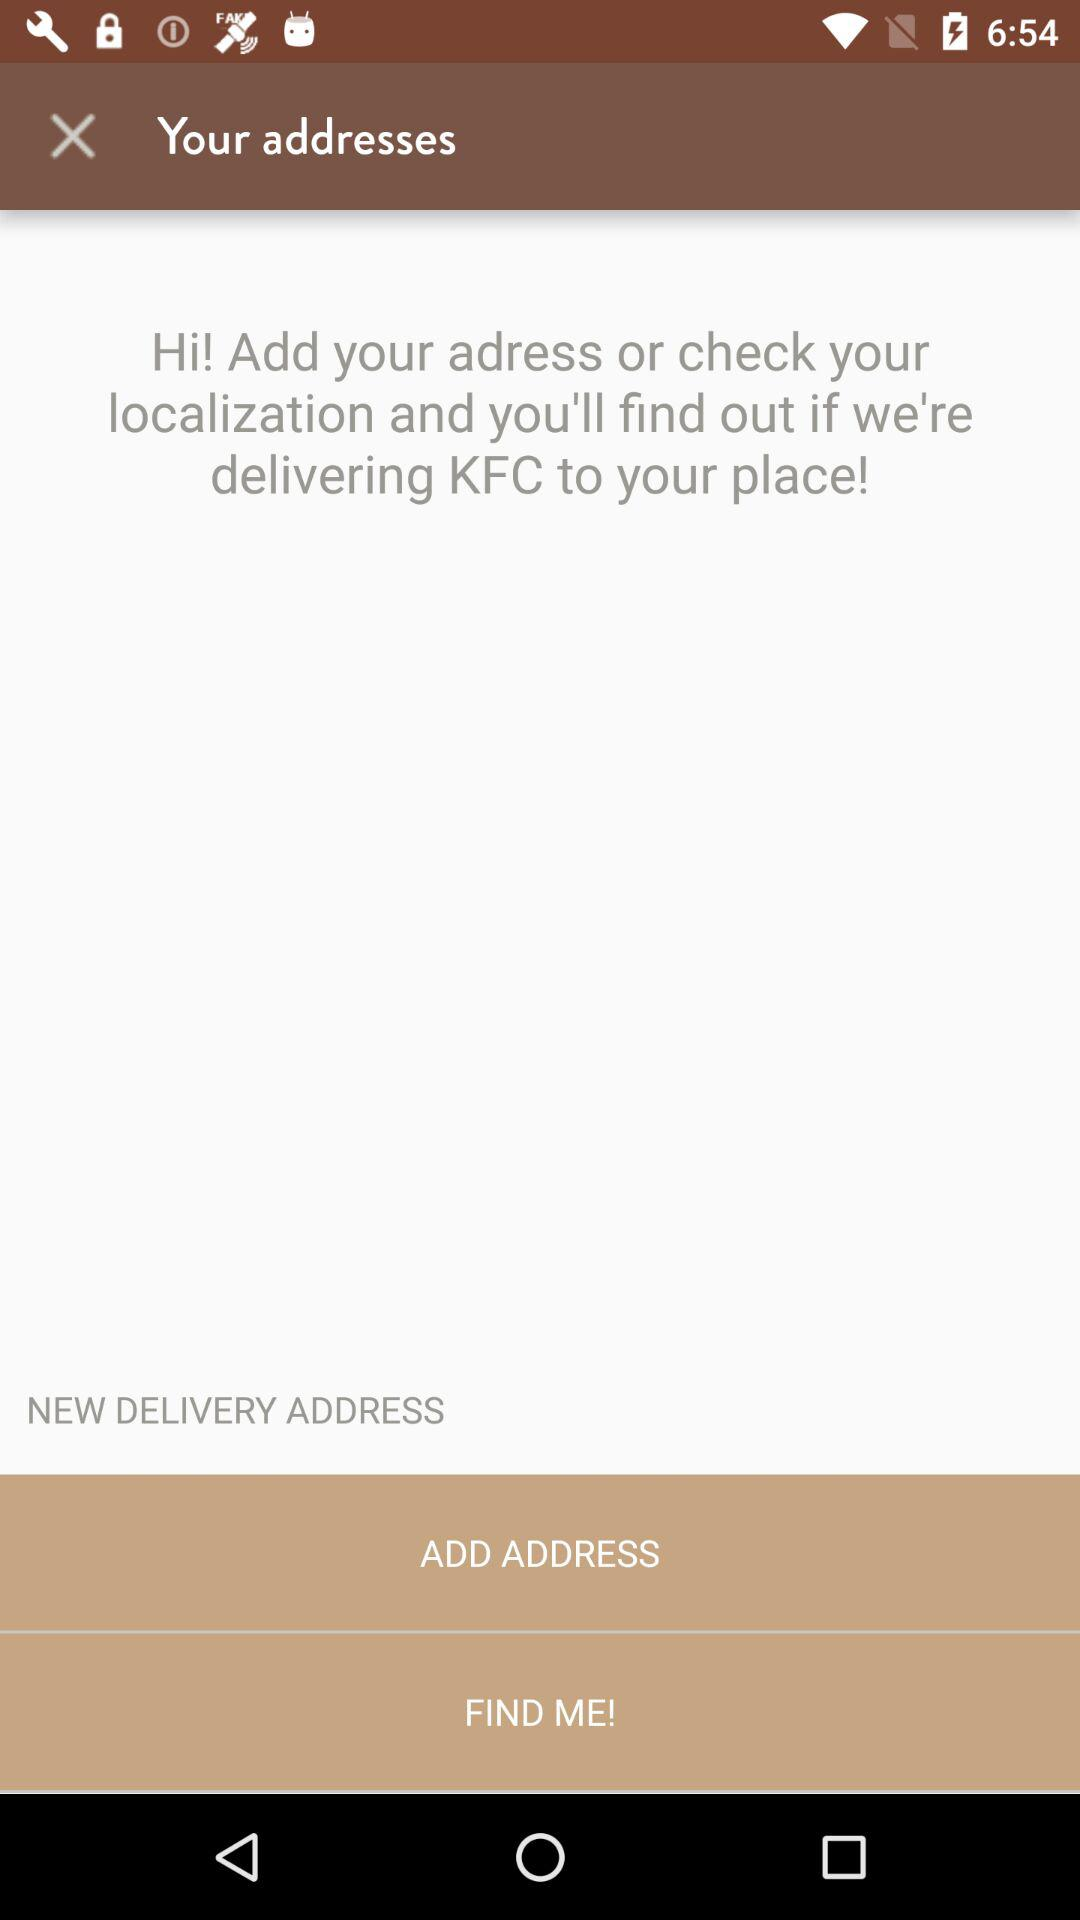Who is delivering?
When the provided information is insufficient, respond with <no answer>. <no answer> 